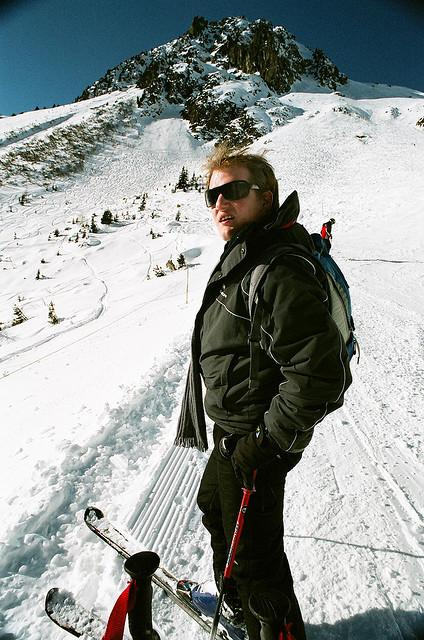What look does the man have on his face? googles 